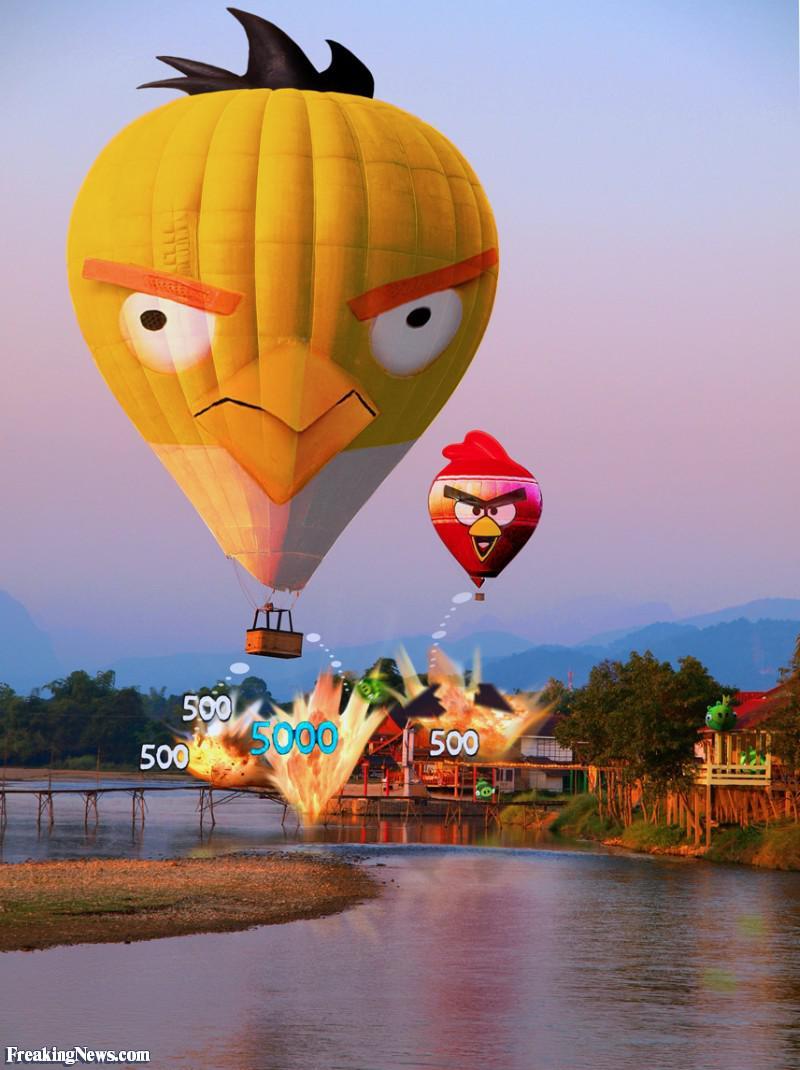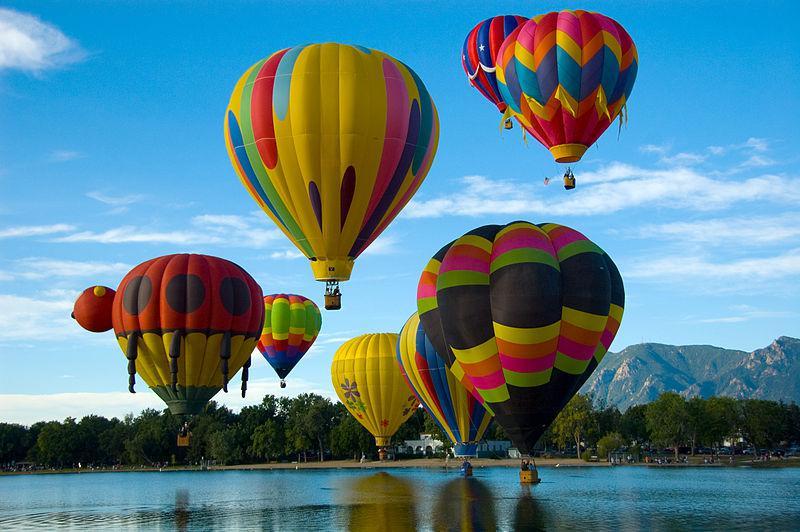The first image is the image on the left, the second image is the image on the right. Considering the images on both sides, is "There are at least four balloons in the image on the left." valid? Answer yes or no. No. The first image is the image on the left, the second image is the image on the right. Examine the images to the left and right. Is the description "In one image, a face is designed on the side of a large yellow hot-air balloon." accurate? Answer yes or no. Yes. 